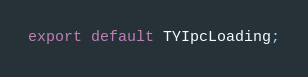Convert code to text. <code><loc_0><loc_0><loc_500><loc_500><_TypeScript_>
export default TYIpcLoading;
</code> 